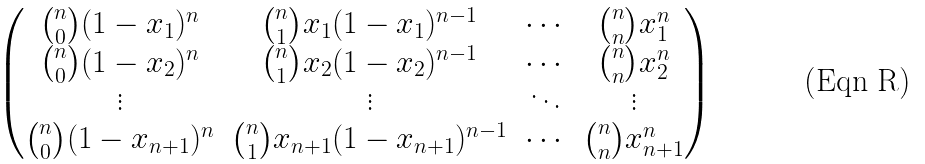Convert formula to latex. <formula><loc_0><loc_0><loc_500><loc_500>\begin{pmatrix} { n \choose 0 } ( 1 - x _ { 1 } ) ^ { n } & { n \choose 1 } x _ { 1 } ( 1 - x _ { 1 } ) ^ { n - 1 } & \cdots & { n \choose n } x _ { 1 } ^ { n } \\ { n \choose 0 } ( 1 - x _ { 2 } ) ^ { n } & { n \choose 1 } x _ { 2 } ( 1 - x _ { 2 } ) ^ { n - 1 } & \cdots & { n \choose n } x _ { 2 } ^ { n } \\ \vdots & \vdots & \ddots & \vdots \\ { n \choose 0 } ( 1 - x _ { n + 1 } ) ^ { n } & { n \choose 1 } x _ { n + 1 } ( 1 - x _ { n + 1 } ) ^ { n - 1 } & \cdots & { n \choose n } x _ { n + 1 } ^ { n } \end{pmatrix}</formula> 